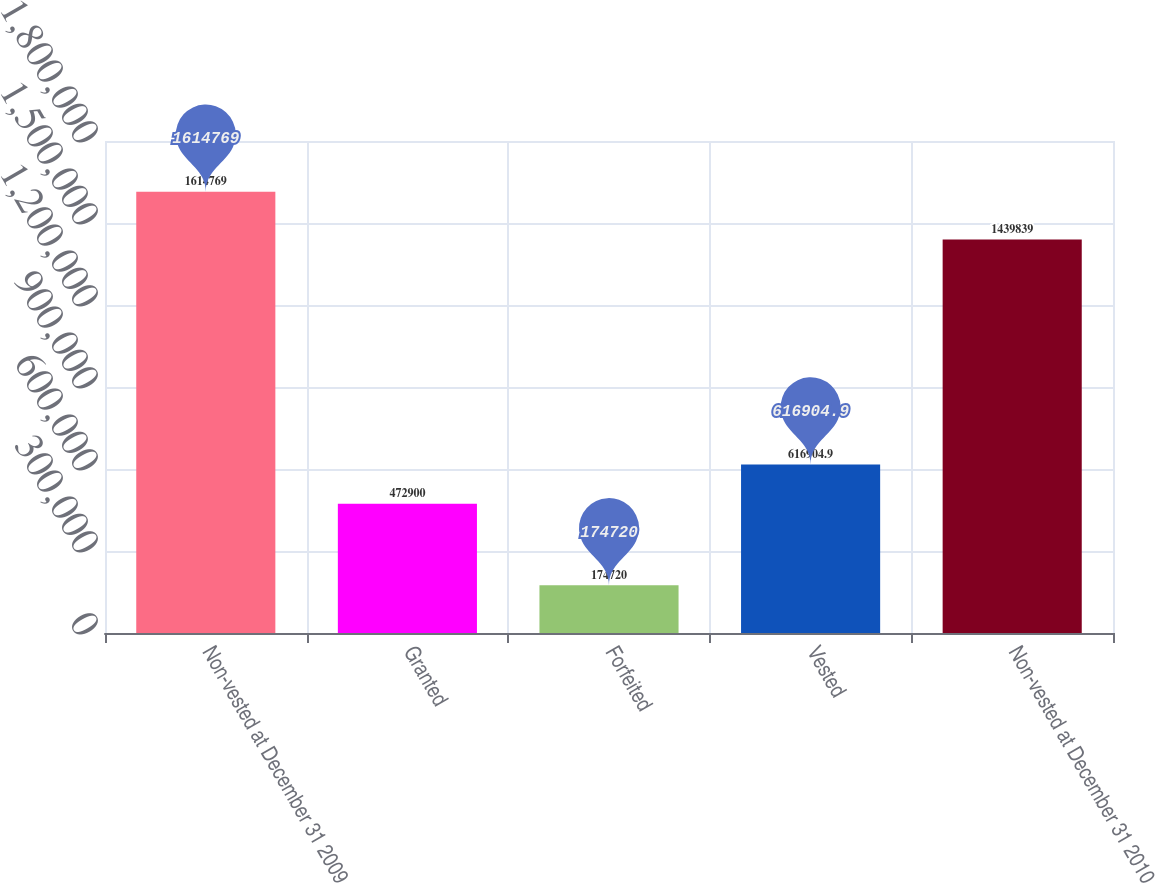Convert chart to OTSL. <chart><loc_0><loc_0><loc_500><loc_500><bar_chart><fcel>Non-vested at December 31 2009<fcel>Granted<fcel>Forfeited<fcel>Vested<fcel>Non-vested at December 31 2010<nl><fcel>1.61477e+06<fcel>472900<fcel>174720<fcel>616905<fcel>1.43984e+06<nl></chart> 